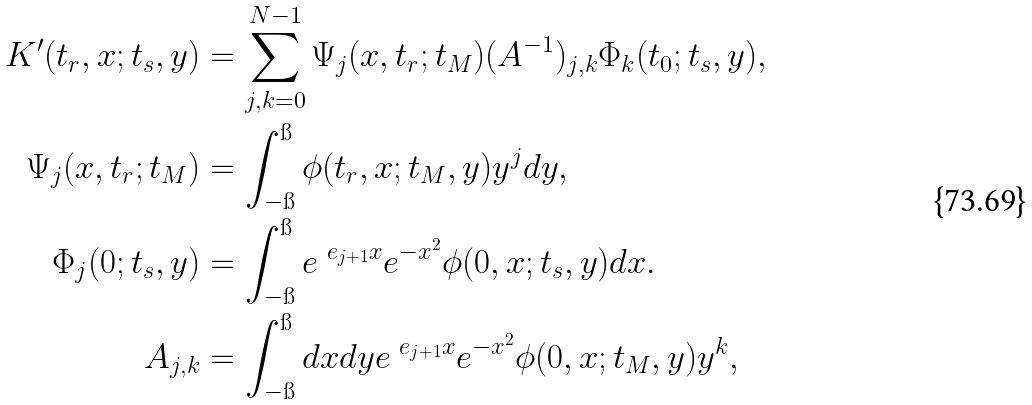Convert formula to latex. <formula><loc_0><loc_0><loc_500><loc_500>K ^ { \prime } ( t _ { r } , x ; t _ { s } , y ) & = \sum _ { j , k = 0 } ^ { N - 1 } \Psi _ { j } ( x , t _ { r } ; t _ { M } ) ( A ^ { - 1 } ) _ { j , k } \Phi _ { k } ( t _ { 0 } ; t _ { s } , y ) , \\ \Psi _ { j } ( x , t _ { r } ; t _ { M } ) & = \int _ { - \i } ^ { \i } \phi ( t _ { r } , x ; t _ { M } , y ) y ^ { j } d y , \\ \Phi _ { j } ( 0 ; t _ { s } , y ) & = \int _ { - \i } ^ { \i } e ^ { \ e _ { j + 1 } x } e ^ { - x ^ { 2 } } \phi ( 0 , x ; t _ { s } , y ) d x . \\ A _ { j , k } & = \int _ { - \i } ^ { \i } d x d y e ^ { \ e _ { j + 1 } x } e ^ { - x ^ { 2 } } \phi ( 0 , x ; t _ { M } , y ) y ^ { k } ,</formula> 